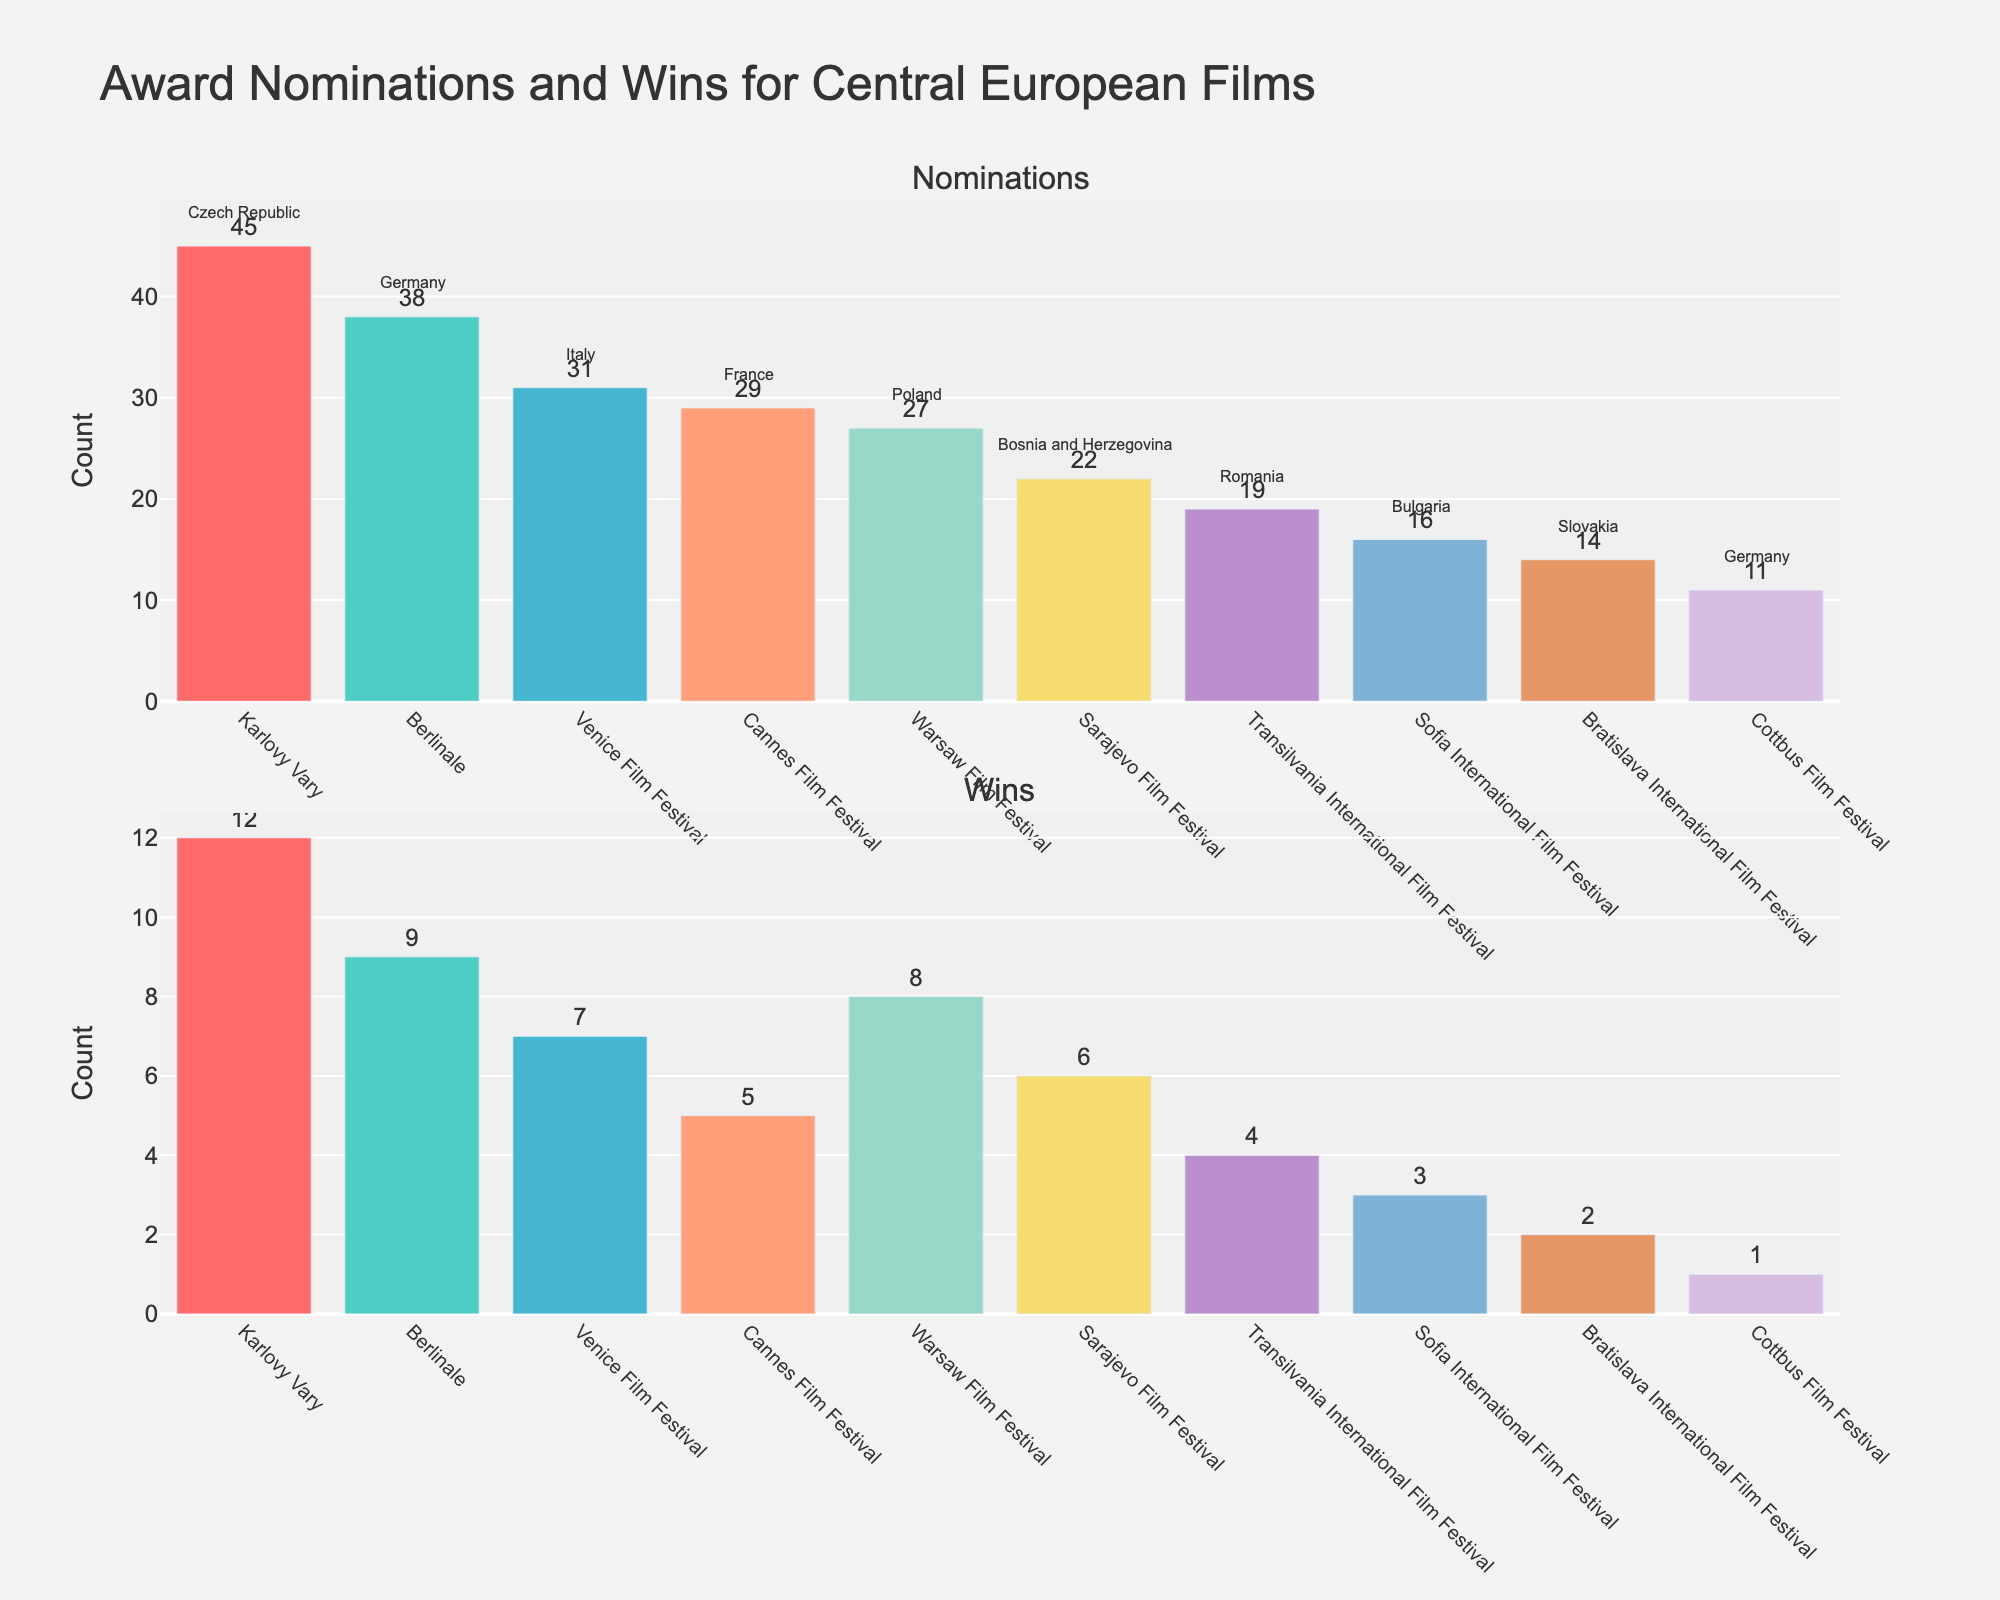How many Central European film festivals are represented in the plots? Count the unique festival names listed on the x-axis. Each unique name represents a different festival.
Answer: 10 Which festival has the highest number of nominations? Identify the festival with the tallest bar in the top subplot, which represents nominations.
Answer: Karlovy Vary Which festival has the lowest number of wins? Identify the festival with the shortest bar in the bottom subplot, which represents wins.
Answer: Cottbus Film Festival What is the total number of nominations for Slovak films? Look for the festival held in Slovakia (Bratislava International Film Festival) in the x-axis of the nominations subplot and note its value.
Answer: 14 How many more nominations does the Karlovy Vary festival have compared to the Bratislava International Film Festival? Subtract the number of nominations for the Bratislava International Film Festival from the number of nominations for the Karlovy Vary festival.
Answer: 31 Which festival has a higher number of wins, the Berlin International Film Festival or the Venice Film Festival? Compare the bar heights representing wins for the Berlinale and Venice Film Festival in the bottom subplot.
Answer: Berlinale What is the average number of wins across all the festivals? Sum the number of wins for all festivals and then divide by the total number of festivals (10). Calculation: (12+9+7+5+8+6+4+3+2+1) / 10 = 5.7
Answer: 5.7 Which film festival hosted in Bulgaria is represented in the plots? Look for the annotation in the top subplot (nominations) that mentions Bulgaria next to it.
Answer: Sofia International Film Festival What is the ratio of nominations to wins for the Warsaw Film Festival? Find the values of nominations and wins for Warsaw Film Festival, then divide the number of nominations by the number of wins. Calculation: 27/8 = 3.375
Answer: 3.375 